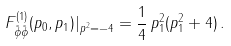<formula> <loc_0><loc_0><loc_500><loc_500>F ^ { ( 1 ) } _ { \tilde { \phi } \tilde { \phi } } ( p _ { 0 } , p _ { 1 } ) | _ { p ^ { 2 } = - 4 } = \frac { 1 } { 4 } \, p _ { 1 } ^ { 2 } ( p _ { 1 } ^ { 2 } + 4 ) \, .</formula> 